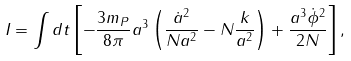Convert formula to latex. <formula><loc_0><loc_0><loc_500><loc_500>I = \int d t \left [ - \frac { 3 m _ { P } } { 8 \pi } a ^ { 3 } \left ( \frac { \dot { a } ^ { 2 } } { N a ^ { 2 } } - N \frac { k } { a ^ { 2 } } \right ) + \frac { a ^ { 3 } \dot { \phi } ^ { 2 } } { 2 N } \right ] ,</formula> 